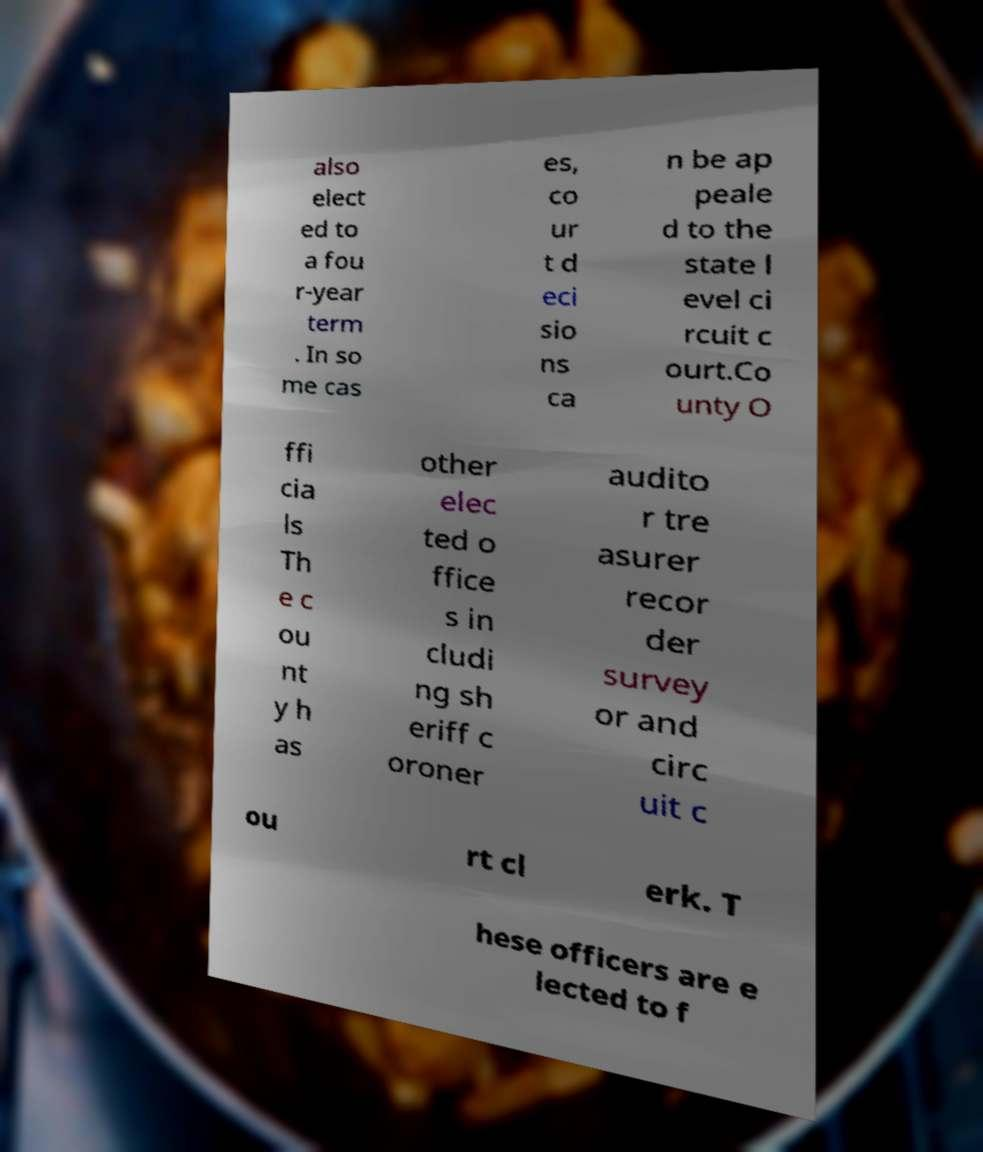Can you read and provide the text displayed in the image?This photo seems to have some interesting text. Can you extract and type it out for me? also elect ed to a fou r-year term . In so me cas es, co ur t d eci sio ns ca n be ap peale d to the state l evel ci rcuit c ourt.Co unty O ffi cia ls Th e c ou nt y h as other elec ted o ffice s in cludi ng sh eriff c oroner audito r tre asurer recor der survey or and circ uit c ou rt cl erk. T hese officers are e lected to f 